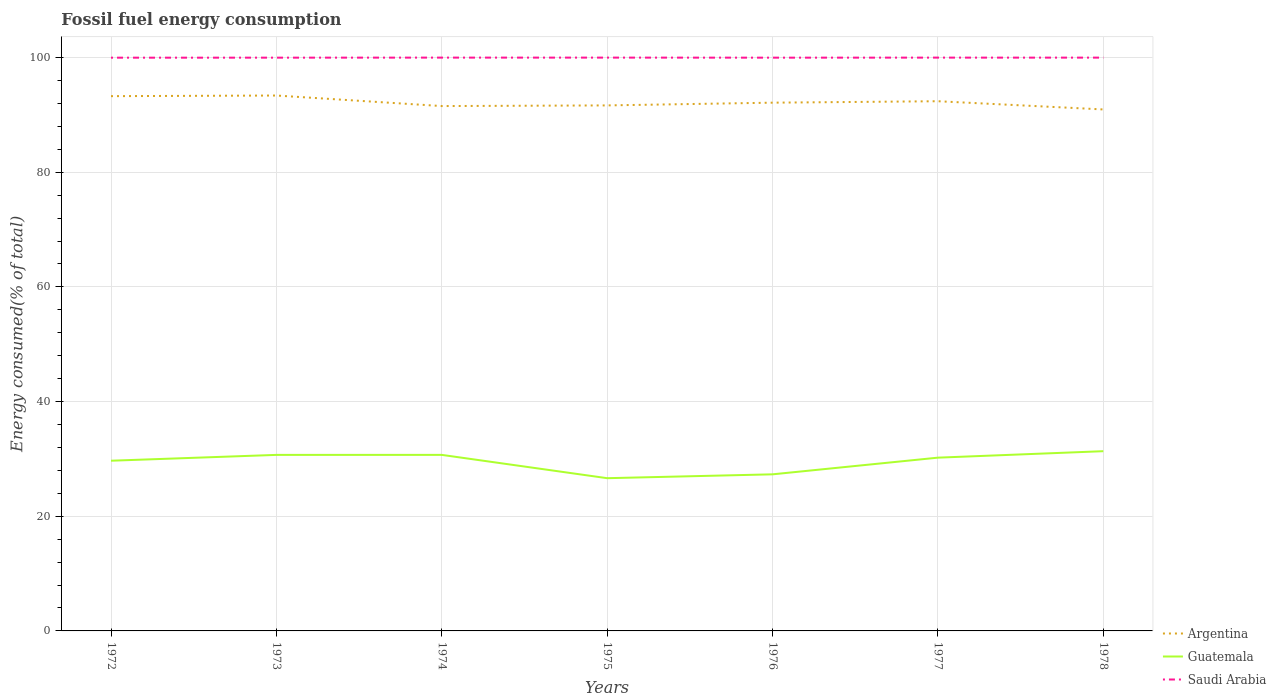How many different coloured lines are there?
Ensure brevity in your answer.  3. Does the line corresponding to Argentina intersect with the line corresponding to Saudi Arabia?
Keep it short and to the point. No. Across all years, what is the maximum percentage of energy consumed in Saudi Arabia?
Ensure brevity in your answer.  99.98. What is the total percentage of energy consumed in Saudi Arabia in the graph?
Your answer should be very brief. 0. What is the difference between the highest and the second highest percentage of energy consumed in Argentina?
Offer a terse response. 2.43. Is the percentage of energy consumed in Guatemala strictly greater than the percentage of energy consumed in Argentina over the years?
Your answer should be compact. Yes. How many years are there in the graph?
Offer a terse response. 7. What is the difference between two consecutive major ticks on the Y-axis?
Make the answer very short. 20. Are the values on the major ticks of Y-axis written in scientific E-notation?
Provide a succinct answer. No. Where does the legend appear in the graph?
Your response must be concise. Bottom right. What is the title of the graph?
Offer a very short reply. Fossil fuel energy consumption. Does "Switzerland" appear as one of the legend labels in the graph?
Provide a succinct answer. No. What is the label or title of the Y-axis?
Your answer should be very brief. Energy consumed(% of total). What is the Energy consumed(% of total) of Argentina in 1972?
Ensure brevity in your answer.  93.27. What is the Energy consumed(% of total) in Guatemala in 1972?
Ensure brevity in your answer.  29.68. What is the Energy consumed(% of total) of Saudi Arabia in 1972?
Offer a terse response. 99.98. What is the Energy consumed(% of total) of Argentina in 1973?
Offer a very short reply. 93.38. What is the Energy consumed(% of total) in Guatemala in 1973?
Offer a very short reply. 30.7. What is the Energy consumed(% of total) of Saudi Arabia in 1973?
Make the answer very short. 99.98. What is the Energy consumed(% of total) of Argentina in 1974?
Provide a succinct answer. 91.54. What is the Energy consumed(% of total) in Guatemala in 1974?
Provide a short and direct response. 30.7. What is the Energy consumed(% of total) of Saudi Arabia in 1974?
Keep it short and to the point. 99.99. What is the Energy consumed(% of total) in Argentina in 1975?
Ensure brevity in your answer.  91.65. What is the Energy consumed(% of total) of Guatemala in 1975?
Your answer should be compact. 26.64. What is the Energy consumed(% of total) of Saudi Arabia in 1975?
Give a very brief answer. 99.99. What is the Energy consumed(% of total) in Argentina in 1976?
Make the answer very short. 92.13. What is the Energy consumed(% of total) in Guatemala in 1976?
Provide a succinct answer. 27.31. What is the Energy consumed(% of total) of Saudi Arabia in 1976?
Provide a short and direct response. 99.98. What is the Energy consumed(% of total) in Argentina in 1977?
Offer a very short reply. 92.38. What is the Energy consumed(% of total) of Guatemala in 1977?
Give a very brief answer. 30.22. What is the Energy consumed(% of total) of Saudi Arabia in 1977?
Your response must be concise. 99.99. What is the Energy consumed(% of total) of Argentina in 1978?
Your answer should be compact. 90.95. What is the Energy consumed(% of total) of Guatemala in 1978?
Give a very brief answer. 31.35. What is the Energy consumed(% of total) of Saudi Arabia in 1978?
Provide a succinct answer. 99.98. Across all years, what is the maximum Energy consumed(% of total) of Argentina?
Provide a short and direct response. 93.38. Across all years, what is the maximum Energy consumed(% of total) in Guatemala?
Provide a succinct answer. 31.35. Across all years, what is the maximum Energy consumed(% of total) of Saudi Arabia?
Offer a terse response. 99.99. Across all years, what is the minimum Energy consumed(% of total) of Argentina?
Offer a very short reply. 90.95. Across all years, what is the minimum Energy consumed(% of total) of Guatemala?
Your answer should be compact. 26.64. Across all years, what is the minimum Energy consumed(% of total) of Saudi Arabia?
Give a very brief answer. 99.98. What is the total Energy consumed(% of total) in Argentina in the graph?
Make the answer very short. 645.29. What is the total Energy consumed(% of total) of Guatemala in the graph?
Keep it short and to the point. 206.6. What is the total Energy consumed(% of total) in Saudi Arabia in the graph?
Offer a very short reply. 699.88. What is the difference between the Energy consumed(% of total) of Argentina in 1972 and that in 1973?
Provide a short and direct response. -0.11. What is the difference between the Energy consumed(% of total) of Guatemala in 1972 and that in 1973?
Offer a very short reply. -1.02. What is the difference between the Energy consumed(% of total) of Saudi Arabia in 1972 and that in 1973?
Provide a succinct answer. -0. What is the difference between the Energy consumed(% of total) in Argentina in 1972 and that in 1974?
Offer a terse response. 1.73. What is the difference between the Energy consumed(% of total) of Guatemala in 1972 and that in 1974?
Provide a succinct answer. -1.02. What is the difference between the Energy consumed(% of total) in Saudi Arabia in 1972 and that in 1974?
Keep it short and to the point. -0.01. What is the difference between the Energy consumed(% of total) in Argentina in 1972 and that in 1975?
Your answer should be very brief. 1.61. What is the difference between the Energy consumed(% of total) of Guatemala in 1972 and that in 1975?
Provide a short and direct response. 3.05. What is the difference between the Energy consumed(% of total) in Saudi Arabia in 1972 and that in 1975?
Ensure brevity in your answer.  -0.01. What is the difference between the Energy consumed(% of total) in Argentina in 1972 and that in 1976?
Your response must be concise. 1.14. What is the difference between the Energy consumed(% of total) of Guatemala in 1972 and that in 1976?
Give a very brief answer. 2.37. What is the difference between the Energy consumed(% of total) in Saudi Arabia in 1972 and that in 1976?
Provide a short and direct response. -0. What is the difference between the Energy consumed(% of total) in Argentina in 1972 and that in 1977?
Your response must be concise. 0.89. What is the difference between the Energy consumed(% of total) of Guatemala in 1972 and that in 1977?
Your answer should be very brief. -0.54. What is the difference between the Energy consumed(% of total) in Saudi Arabia in 1972 and that in 1977?
Your response must be concise. -0.01. What is the difference between the Energy consumed(% of total) in Argentina in 1972 and that in 1978?
Your answer should be very brief. 2.32. What is the difference between the Energy consumed(% of total) of Guatemala in 1972 and that in 1978?
Your response must be concise. -1.66. What is the difference between the Energy consumed(% of total) in Saudi Arabia in 1972 and that in 1978?
Provide a short and direct response. -0.01. What is the difference between the Energy consumed(% of total) of Argentina in 1973 and that in 1974?
Give a very brief answer. 1.84. What is the difference between the Energy consumed(% of total) of Guatemala in 1973 and that in 1974?
Make the answer very short. -0. What is the difference between the Energy consumed(% of total) in Saudi Arabia in 1973 and that in 1974?
Offer a very short reply. -0.01. What is the difference between the Energy consumed(% of total) in Argentina in 1973 and that in 1975?
Your response must be concise. 1.72. What is the difference between the Energy consumed(% of total) of Guatemala in 1973 and that in 1975?
Keep it short and to the point. 4.06. What is the difference between the Energy consumed(% of total) in Saudi Arabia in 1973 and that in 1975?
Provide a short and direct response. -0.01. What is the difference between the Energy consumed(% of total) in Argentina in 1973 and that in 1976?
Make the answer very short. 1.25. What is the difference between the Energy consumed(% of total) of Guatemala in 1973 and that in 1976?
Provide a short and direct response. 3.39. What is the difference between the Energy consumed(% of total) of Saudi Arabia in 1973 and that in 1976?
Keep it short and to the point. 0. What is the difference between the Energy consumed(% of total) in Argentina in 1973 and that in 1977?
Your response must be concise. 1. What is the difference between the Energy consumed(% of total) of Guatemala in 1973 and that in 1977?
Offer a very short reply. 0.48. What is the difference between the Energy consumed(% of total) in Saudi Arabia in 1973 and that in 1977?
Your answer should be very brief. -0.01. What is the difference between the Energy consumed(% of total) of Argentina in 1973 and that in 1978?
Offer a terse response. 2.43. What is the difference between the Energy consumed(% of total) of Guatemala in 1973 and that in 1978?
Ensure brevity in your answer.  -0.65. What is the difference between the Energy consumed(% of total) in Saudi Arabia in 1973 and that in 1978?
Offer a terse response. -0. What is the difference between the Energy consumed(% of total) in Argentina in 1974 and that in 1975?
Keep it short and to the point. -0.11. What is the difference between the Energy consumed(% of total) in Guatemala in 1974 and that in 1975?
Offer a very short reply. 4.06. What is the difference between the Energy consumed(% of total) of Saudi Arabia in 1974 and that in 1975?
Give a very brief answer. -0. What is the difference between the Energy consumed(% of total) in Argentina in 1974 and that in 1976?
Make the answer very short. -0.59. What is the difference between the Energy consumed(% of total) of Guatemala in 1974 and that in 1976?
Offer a terse response. 3.39. What is the difference between the Energy consumed(% of total) in Saudi Arabia in 1974 and that in 1976?
Your answer should be compact. 0.01. What is the difference between the Energy consumed(% of total) of Argentina in 1974 and that in 1977?
Keep it short and to the point. -0.84. What is the difference between the Energy consumed(% of total) in Guatemala in 1974 and that in 1977?
Ensure brevity in your answer.  0.48. What is the difference between the Energy consumed(% of total) in Saudi Arabia in 1974 and that in 1977?
Provide a succinct answer. 0. What is the difference between the Energy consumed(% of total) in Argentina in 1974 and that in 1978?
Offer a terse response. 0.59. What is the difference between the Energy consumed(% of total) of Guatemala in 1974 and that in 1978?
Your answer should be compact. -0.64. What is the difference between the Energy consumed(% of total) in Saudi Arabia in 1974 and that in 1978?
Offer a terse response. 0. What is the difference between the Energy consumed(% of total) in Argentina in 1975 and that in 1976?
Provide a short and direct response. -0.48. What is the difference between the Energy consumed(% of total) of Guatemala in 1975 and that in 1976?
Ensure brevity in your answer.  -0.67. What is the difference between the Energy consumed(% of total) in Saudi Arabia in 1975 and that in 1976?
Keep it short and to the point. 0.01. What is the difference between the Energy consumed(% of total) of Argentina in 1975 and that in 1977?
Your response must be concise. -0.73. What is the difference between the Energy consumed(% of total) in Guatemala in 1975 and that in 1977?
Keep it short and to the point. -3.58. What is the difference between the Energy consumed(% of total) of Saudi Arabia in 1975 and that in 1977?
Make the answer very short. 0. What is the difference between the Energy consumed(% of total) in Argentina in 1975 and that in 1978?
Offer a terse response. 0.71. What is the difference between the Energy consumed(% of total) in Guatemala in 1975 and that in 1978?
Give a very brief answer. -4.71. What is the difference between the Energy consumed(% of total) in Saudi Arabia in 1975 and that in 1978?
Offer a very short reply. 0. What is the difference between the Energy consumed(% of total) in Argentina in 1976 and that in 1977?
Your answer should be very brief. -0.25. What is the difference between the Energy consumed(% of total) of Guatemala in 1976 and that in 1977?
Offer a terse response. -2.91. What is the difference between the Energy consumed(% of total) of Saudi Arabia in 1976 and that in 1977?
Provide a short and direct response. -0.01. What is the difference between the Energy consumed(% of total) of Argentina in 1976 and that in 1978?
Provide a succinct answer. 1.18. What is the difference between the Energy consumed(% of total) in Guatemala in 1976 and that in 1978?
Offer a terse response. -4.03. What is the difference between the Energy consumed(% of total) of Saudi Arabia in 1976 and that in 1978?
Offer a terse response. -0.01. What is the difference between the Energy consumed(% of total) in Argentina in 1977 and that in 1978?
Provide a succinct answer. 1.43. What is the difference between the Energy consumed(% of total) in Guatemala in 1977 and that in 1978?
Offer a terse response. -1.13. What is the difference between the Energy consumed(% of total) of Saudi Arabia in 1977 and that in 1978?
Your answer should be very brief. 0. What is the difference between the Energy consumed(% of total) in Argentina in 1972 and the Energy consumed(% of total) in Guatemala in 1973?
Your response must be concise. 62.57. What is the difference between the Energy consumed(% of total) of Argentina in 1972 and the Energy consumed(% of total) of Saudi Arabia in 1973?
Give a very brief answer. -6.71. What is the difference between the Energy consumed(% of total) in Guatemala in 1972 and the Energy consumed(% of total) in Saudi Arabia in 1973?
Offer a very short reply. -70.3. What is the difference between the Energy consumed(% of total) in Argentina in 1972 and the Energy consumed(% of total) in Guatemala in 1974?
Provide a succinct answer. 62.56. What is the difference between the Energy consumed(% of total) in Argentina in 1972 and the Energy consumed(% of total) in Saudi Arabia in 1974?
Provide a succinct answer. -6.72. What is the difference between the Energy consumed(% of total) in Guatemala in 1972 and the Energy consumed(% of total) in Saudi Arabia in 1974?
Keep it short and to the point. -70.3. What is the difference between the Energy consumed(% of total) of Argentina in 1972 and the Energy consumed(% of total) of Guatemala in 1975?
Keep it short and to the point. 66.63. What is the difference between the Energy consumed(% of total) of Argentina in 1972 and the Energy consumed(% of total) of Saudi Arabia in 1975?
Keep it short and to the point. -6.72. What is the difference between the Energy consumed(% of total) of Guatemala in 1972 and the Energy consumed(% of total) of Saudi Arabia in 1975?
Give a very brief answer. -70.31. What is the difference between the Energy consumed(% of total) in Argentina in 1972 and the Energy consumed(% of total) in Guatemala in 1976?
Make the answer very short. 65.96. What is the difference between the Energy consumed(% of total) of Argentina in 1972 and the Energy consumed(% of total) of Saudi Arabia in 1976?
Your answer should be compact. -6.71. What is the difference between the Energy consumed(% of total) of Guatemala in 1972 and the Energy consumed(% of total) of Saudi Arabia in 1976?
Offer a terse response. -70.3. What is the difference between the Energy consumed(% of total) of Argentina in 1972 and the Energy consumed(% of total) of Guatemala in 1977?
Your answer should be compact. 63.05. What is the difference between the Energy consumed(% of total) in Argentina in 1972 and the Energy consumed(% of total) in Saudi Arabia in 1977?
Make the answer very short. -6.72. What is the difference between the Energy consumed(% of total) in Guatemala in 1972 and the Energy consumed(% of total) in Saudi Arabia in 1977?
Give a very brief answer. -70.3. What is the difference between the Energy consumed(% of total) of Argentina in 1972 and the Energy consumed(% of total) of Guatemala in 1978?
Offer a terse response. 61.92. What is the difference between the Energy consumed(% of total) of Argentina in 1972 and the Energy consumed(% of total) of Saudi Arabia in 1978?
Offer a terse response. -6.72. What is the difference between the Energy consumed(% of total) of Guatemala in 1972 and the Energy consumed(% of total) of Saudi Arabia in 1978?
Ensure brevity in your answer.  -70.3. What is the difference between the Energy consumed(% of total) of Argentina in 1973 and the Energy consumed(% of total) of Guatemala in 1974?
Ensure brevity in your answer.  62.67. What is the difference between the Energy consumed(% of total) in Argentina in 1973 and the Energy consumed(% of total) in Saudi Arabia in 1974?
Keep it short and to the point. -6.61. What is the difference between the Energy consumed(% of total) in Guatemala in 1973 and the Energy consumed(% of total) in Saudi Arabia in 1974?
Provide a succinct answer. -69.29. What is the difference between the Energy consumed(% of total) of Argentina in 1973 and the Energy consumed(% of total) of Guatemala in 1975?
Provide a short and direct response. 66.74. What is the difference between the Energy consumed(% of total) of Argentina in 1973 and the Energy consumed(% of total) of Saudi Arabia in 1975?
Keep it short and to the point. -6.61. What is the difference between the Energy consumed(% of total) of Guatemala in 1973 and the Energy consumed(% of total) of Saudi Arabia in 1975?
Offer a very short reply. -69.29. What is the difference between the Energy consumed(% of total) of Argentina in 1973 and the Energy consumed(% of total) of Guatemala in 1976?
Offer a terse response. 66.07. What is the difference between the Energy consumed(% of total) of Argentina in 1973 and the Energy consumed(% of total) of Saudi Arabia in 1976?
Keep it short and to the point. -6.6. What is the difference between the Energy consumed(% of total) in Guatemala in 1973 and the Energy consumed(% of total) in Saudi Arabia in 1976?
Keep it short and to the point. -69.28. What is the difference between the Energy consumed(% of total) of Argentina in 1973 and the Energy consumed(% of total) of Guatemala in 1977?
Ensure brevity in your answer.  63.16. What is the difference between the Energy consumed(% of total) in Argentina in 1973 and the Energy consumed(% of total) in Saudi Arabia in 1977?
Provide a short and direct response. -6.61. What is the difference between the Energy consumed(% of total) in Guatemala in 1973 and the Energy consumed(% of total) in Saudi Arabia in 1977?
Provide a short and direct response. -69.29. What is the difference between the Energy consumed(% of total) in Argentina in 1973 and the Energy consumed(% of total) in Guatemala in 1978?
Provide a succinct answer. 62.03. What is the difference between the Energy consumed(% of total) of Argentina in 1973 and the Energy consumed(% of total) of Saudi Arabia in 1978?
Give a very brief answer. -6.61. What is the difference between the Energy consumed(% of total) of Guatemala in 1973 and the Energy consumed(% of total) of Saudi Arabia in 1978?
Keep it short and to the point. -69.28. What is the difference between the Energy consumed(% of total) in Argentina in 1974 and the Energy consumed(% of total) in Guatemala in 1975?
Ensure brevity in your answer.  64.9. What is the difference between the Energy consumed(% of total) of Argentina in 1974 and the Energy consumed(% of total) of Saudi Arabia in 1975?
Give a very brief answer. -8.45. What is the difference between the Energy consumed(% of total) of Guatemala in 1974 and the Energy consumed(% of total) of Saudi Arabia in 1975?
Provide a short and direct response. -69.29. What is the difference between the Energy consumed(% of total) of Argentina in 1974 and the Energy consumed(% of total) of Guatemala in 1976?
Keep it short and to the point. 64.23. What is the difference between the Energy consumed(% of total) in Argentina in 1974 and the Energy consumed(% of total) in Saudi Arabia in 1976?
Your response must be concise. -8.44. What is the difference between the Energy consumed(% of total) of Guatemala in 1974 and the Energy consumed(% of total) of Saudi Arabia in 1976?
Your answer should be very brief. -69.28. What is the difference between the Energy consumed(% of total) of Argentina in 1974 and the Energy consumed(% of total) of Guatemala in 1977?
Your response must be concise. 61.32. What is the difference between the Energy consumed(% of total) of Argentina in 1974 and the Energy consumed(% of total) of Saudi Arabia in 1977?
Your answer should be compact. -8.45. What is the difference between the Energy consumed(% of total) in Guatemala in 1974 and the Energy consumed(% of total) in Saudi Arabia in 1977?
Your answer should be compact. -69.28. What is the difference between the Energy consumed(% of total) of Argentina in 1974 and the Energy consumed(% of total) of Guatemala in 1978?
Your response must be concise. 60.19. What is the difference between the Energy consumed(% of total) in Argentina in 1974 and the Energy consumed(% of total) in Saudi Arabia in 1978?
Provide a short and direct response. -8.45. What is the difference between the Energy consumed(% of total) in Guatemala in 1974 and the Energy consumed(% of total) in Saudi Arabia in 1978?
Keep it short and to the point. -69.28. What is the difference between the Energy consumed(% of total) in Argentina in 1975 and the Energy consumed(% of total) in Guatemala in 1976?
Offer a terse response. 64.34. What is the difference between the Energy consumed(% of total) of Argentina in 1975 and the Energy consumed(% of total) of Saudi Arabia in 1976?
Provide a short and direct response. -8.33. What is the difference between the Energy consumed(% of total) of Guatemala in 1975 and the Energy consumed(% of total) of Saudi Arabia in 1976?
Offer a terse response. -73.34. What is the difference between the Energy consumed(% of total) in Argentina in 1975 and the Energy consumed(% of total) in Guatemala in 1977?
Ensure brevity in your answer.  61.43. What is the difference between the Energy consumed(% of total) of Argentina in 1975 and the Energy consumed(% of total) of Saudi Arabia in 1977?
Make the answer very short. -8.34. What is the difference between the Energy consumed(% of total) in Guatemala in 1975 and the Energy consumed(% of total) in Saudi Arabia in 1977?
Offer a very short reply. -73.35. What is the difference between the Energy consumed(% of total) in Argentina in 1975 and the Energy consumed(% of total) in Guatemala in 1978?
Your answer should be compact. 60.31. What is the difference between the Energy consumed(% of total) in Argentina in 1975 and the Energy consumed(% of total) in Saudi Arabia in 1978?
Give a very brief answer. -8.33. What is the difference between the Energy consumed(% of total) in Guatemala in 1975 and the Energy consumed(% of total) in Saudi Arabia in 1978?
Provide a succinct answer. -73.35. What is the difference between the Energy consumed(% of total) of Argentina in 1976 and the Energy consumed(% of total) of Guatemala in 1977?
Make the answer very short. 61.91. What is the difference between the Energy consumed(% of total) of Argentina in 1976 and the Energy consumed(% of total) of Saudi Arabia in 1977?
Offer a very short reply. -7.86. What is the difference between the Energy consumed(% of total) of Guatemala in 1976 and the Energy consumed(% of total) of Saudi Arabia in 1977?
Offer a terse response. -72.68. What is the difference between the Energy consumed(% of total) in Argentina in 1976 and the Energy consumed(% of total) in Guatemala in 1978?
Provide a short and direct response. 60.78. What is the difference between the Energy consumed(% of total) in Argentina in 1976 and the Energy consumed(% of total) in Saudi Arabia in 1978?
Give a very brief answer. -7.85. What is the difference between the Energy consumed(% of total) of Guatemala in 1976 and the Energy consumed(% of total) of Saudi Arabia in 1978?
Make the answer very short. -72.67. What is the difference between the Energy consumed(% of total) in Argentina in 1977 and the Energy consumed(% of total) in Guatemala in 1978?
Ensure brevity in your answer.  61.03. What is the difference between the Energy consumed(% of total) of Argentina in 1977 and the Energy consumed(% of total) of Saudi Arabia in 1978?
Provide a succinct answer. -7.6. What is the difference between the Energy consumed(% of total) of Guatemala in 1977 and the Energy consumed(% of total) of Saudi Arabia in 1978?
Offer a very short reply. -69.77. What is the average Energy consumed(% of total) of Argentina per year?
Your response must be concise. 92.18. What is the average Energy consumed(% of total) of Guatemala per year?
Provide a short and direct response. 29.51. What is the average Energy consumed(% of total) of Saudi Arabia per year?
Give a very brief answer. 99.98. In the year 1972, what is the difference between the Energy consumed(% of total) of Argentina and Energy consumed(% of total) of Guatemala?
Offer a terse response. 63.58. In the year 1972, what is the difference between the Energy consumed(% of total) of Argentina and Energy consumed(% of total) of Saudi Arabia?
Offer a terse response. -6.71. In the year 1972, what is the difference between the Energy consumed(% of total) of Guatemala and Energy consumed(% of total) of Saudi Arabia?
Your answer should be compact. -70.29. In the year 1973, what is the difference between the Energy consumed(% of total) in Argentina and Energy consumed(% of total) in Guatemala?
Your response must be concise. 62.68. In the year 1973, what is the difference between the Energy consumed(% of total) in Argentina and Energy consumed(% of total) in Saudi Arabia?
Offer a very short reply. -6.6. In the year 1973, what is the difference between the Energy consumed(% of total) of Guatemala and Energy consumed(% of total) of Saudi Arabia?
Offer a terse response. -69.28. In the year 1974, what is the difference between the Energy consumed(% of total) of Argentina and Energy consumed(% of total) of Guatemala?
Provide a short and direct response. 60.84. In the year 1974, what is the difference between the Energy consumed(% of total) in Argentina and Energy consumed(% of total) in Saudi Arabia?
Your response must be concise. -8.45. In the year 1974, what is the difference between the Energy consumed(% of total) in Guatemala and Energy consumed(% of total) in Saudi Arabia?
Your answer should be compact. -69.29. In the year 1975, what is the difference between the Energy consumed(% of total) of Argentina and Energy consumed(% of total) of Guatemala?
Provide a short and direct response. 65.01. In the year 1975, what is the difference between the Energy consumed(% of total) of Argentina and Energy consumed(% of total) of Saudi Arabia?
Offer a terse response. -8.34. In the year 1975, what is the difference between the Energy consumed(% of total) in Guatemala and Energy consumed(% of total) in Saudi Arabia?
Your response must be concise. -73.35. In the year 1976, what is the difference between the Energy consumed(% of total) of Argentina and Energy consumed(% of total) of Guatemala?
Your answer should be compact. 64.82. In the year 1976, what is the difference between the Energy consumed(% of total) in Argentina and Energy consumed(% of total) in Saudi Arabia?
Provide a succinct answer. -7.85. In the year 1976, what is the difference between the Energy consumed(% of total) in Guatemala and Energy consumed(% of total) in Saudi Arabia?
Your answer should be very brief. -72.67. In the year 1977, what is the difference between the Energy consumed(% of total) in Argentina and Energy consumed(% of total) in Guatemala?
Offer a very short reply. 62.16. In the year 1977, what is the difference between the Energy consumed(% of total) of Argentina and Energy consumed(% of total) of Saudi Arabia?
Keep it short and to the point. -7.61. In the year 1977, what is the difference between the Energy consumed(% of total) in Guatemala and Energy consumed(% of total) in Saudi Arabia?
Make the answer very short. -69.77. In the year 1978, what is the difference between the Energy consumed(% of total) in Argentina and Energy consumed(% of total) in Guatemala?
Ensure brevity in your answer.  59.6. In the year 1978, what is the difference between the Energy consumed(% of total) in Argentina and Energy consumed(% of total) in Saudi Arabia?
Your answer should be very brief. -9.04. In the year 1978, what is the difference between the Energy consumed(% of total) in Guatemala and Energy consumed(% of total) in Saudi Arabia?
Ensure brevity in your answer.  -68.64. What is the ratio of the Energy consumed(% of total) in Argentina in 1972 to that in 1973?
Your answer should be compact. 1. What is the ratio of the Energy consumed(% of total) of Guatemala in 1972 to that in 1973?
Your answer should be very brief. 0.97. What is the ratio of the Energy consumed(% of total) in Saudi Arabia in 1972 to that in 1973?
Give a very brief answer. 1. What is the ratio of the Energy consumed(% of total) of Argentina in 1972 to that in 1974?
Offer a very short reply. 1.02. What is the ratio of the Energy consumed(% of total) in Guatemala in 1972 to that in 1974?
Your response must be concise. 0.97. What is the ratio of the Energy consumed(% of total) of Argentina in 1972 to that in 1975?
Keep it short and to the point. 1.02. What is the ratio of the Energy consumed(% of total) of Guatemala in 1972 to that in 1975?
Offer a very short reply. 1.11. What is the ratio of the Energy consumed(% of total) of Argentina in 1972 to that in 1976?
Ensure brevity in your answer.  1.01. What is the ratio of the Energy consumed(% of total) of Guatemala in 1972 to that in 1976?
Your response must be concise. 1.09. What is the ratio of the Energy consumed(% of total) in Argentina in 1972 to that in 1977?
Offer a terse response. 1.01. What is the ratio of the Energy consumed(% of total) of Guatemala in 1972 to that in 1977?
Provide a succinct answer. 0.98. What is the ratio of the Energy consumed(% of total) of Saudi Arabia in 1972 to that in 1977?
Your response must be concise. 1. What is the ratio of the Energy consumed(% of total) of Argentina in 1972 to that in 1978?
Your answer should be very brief. 1.03. What is the ratio of the Energy consumed(% of total) of Guatemala in 1972 to that in 1978?
Give a very brief answer. 0.95. What is the ratio of the Energy consumed(% of total) in Argentina in 1973 to that in 1974?
Provide a short and direct response. 1.02. What is the ratio of the Energy consumed(% of total) in Argentina in 1973 to that in 1975?
Your answer should be very brief. 1.02. What is the ratio of the Energy consumed(% of total) in Guatemala in 1973 to that in 1975?
Your response must be concise. 1.15. What is the ratio of the Energy consumed(% of total) of Saudi Arabia in 1973 to that in 1975?
Ensure brevity in your answer.  1. What is the ratio of the Energy consumed(% of total) of Argentina in 1973 to that in 1976?
Provide a short and direct response. 1.01. What is the ratio of the Energy consumed(% of total) of Guatemala in 1973 to that in 1976?
Provide a short and direct response. 1.12. What is the ratio of the Energy consumed(% of total) in Saudi Arabia in 1973 to that in 1976?
Provide a short and direct response. 1. What is the ratio of the Energy consumed(% of total) of Argentina in 1973 to that in 1977?
Ensure brevity in your answer.  1.01. What is the ratio of the Energy consumed(% of total) of Guatemala in 1973 to that in 1977?
Offer a very short reply. 1.02. What is the ratio of the Energy consumed(% of total) in Saudi Arabia in 1973 to that in 1977?
Your answer should be very brief. 1. What is the ratio of the Energy consumed(% of total) in Argentina in 1973 to that in 1978?
Your answer should be very brief. 1.03. What is the ratio of the Energy consumed(% of total) in Guatemala in 1973 to that in 1978?
Offer a terse response. 0.98. What is the ratio of the Energy consumed(% of total) of Saudi Arabia in 1973 to that in 1978?
Provide a short and direct response. 1. What is the ratio of the Energy consumed(% of total) in Argentina in 1974 to that in 1975?
Ensure brevity in your answer.  1. What is the ratio of the Energy consumed(% of total) in Guatemala in 1974 to that in 1975?
Your response must be concise. 1.15. What is the ratio of the Energy consumed(% of total) of Guatemala in 1974 to that in 1976?
Provide a succinct answer. 1.12. What is the ratio of the Energy consumed(% of total) in Saudi Arabia in 1974 to that in 1976?
Make the answer very short. 1. What is the ratio of the Energy consumed(% of total) of Argentina in 1974 to that in 1977?
Provide a short and direct response. 0.99. What is the ratio of the Energy consumed(% of total) of Saudi Arabia in 1974 to that in 1977?
Keep it short and to the point. 1. What is the ratio of the Energy consumed(% of total) of Argentina in 1974 to that in 1978?
Offer a very short reply. 1.01. What is the ratio of the Energy consumed(% of total) in Guatemala in 1974 to that in 1978?
Give a very brief answer. 0.98. What is the ratio of the Energy consumed(% of total) of Saudi Arabia in 1974 to that in 1978?
Your answer should be very brief. 1. What is the ratio of the Energy consumed(% of total) in Argentina in 1975 to that in 1976?
Ensure brevity in your answer.  0.99. What is the ratio of the Energy consumed(% of total) in Guatemala in 1975 to that in 1976?
Your answer should be very brief. 0.98. What is the ratio of the Energy consumed(% of total) of Saudi Arabia in 1975 to that in 1976?
Offer a very short reply. 1. What is the ratio of the Energy consumed(% of total) in Guatemala in 1975 to that in 1977?
Make the answer very short. 0.88. What is the ratio of the Energy consumed(% of total) of Saudi Arabia in 1975 to that in 1977?
Make the answer very short. 1. What is the ratio of the Energy consumed(% of total) in Argentina in 1975 to that in 1978?
Offer a terse response. 1.01. What is the ratio of the Energy consumed(% of total) of Guatemala in 1975 to that in 1978?
Your answer should be compact. 0.85. What is the ratio of the Energy consumed(% of total) in Argentina in 1976 to that in 1977?
Give a very brief answer. 1. What is the ratio of the Energy consumed(% of total) of Guatemala in 1976 to that in 1977?
Your answer should be very brief. 0.9. What is the ratio of the Energy consumed(% of total) of Saudi Arabia in 1976 to that in 1977?
Ensure brevity in your answer.  1. What is the ratio of the Energy consumed(% of total) in Guatemala in 1976 to that in 1978?
Your answer should be compact. 0.87. What is the ratio of the Energy consumed(% of total) in Argentina in 1977 to that in 1978?
Provide a short and direct response. 1.02. What is the ratio of the Energy consumed(% of total) of Guatemala in 1977 to that in 1978?
Give a very brief answer. 0.96. What is the ratio of the Energy consumed(% of total) in Saudi Arabia in 1977 to that in 1978?
Keep it short and to the point. 1. What is the difference between the highest and the second highest Energy consumed(% of total) of Argentina?
Make the answer very short. 0.11. What is the difference between the highest and the second highest Energy consumed(% of total) of Guatemala?
Keep it short and to the point. 0.64. What is the difference between the highest and the second highest Energy consumed(% of total) in Saudi Arabia?
Offer a terse response. 0. What is the difference between the highest and the lowest Energy consumed(% of total) in Argentina?
Offer a terse response. 2.43. What is the difference between the highest and the lowest Energy consumed(% of total) in Guatemala?
Your answer should be compact. 4.71. What is the difference between the highest and the lowest Energy consumed(% of total) in Saudi Arabia?
Your answer should be compact. 0.01. 